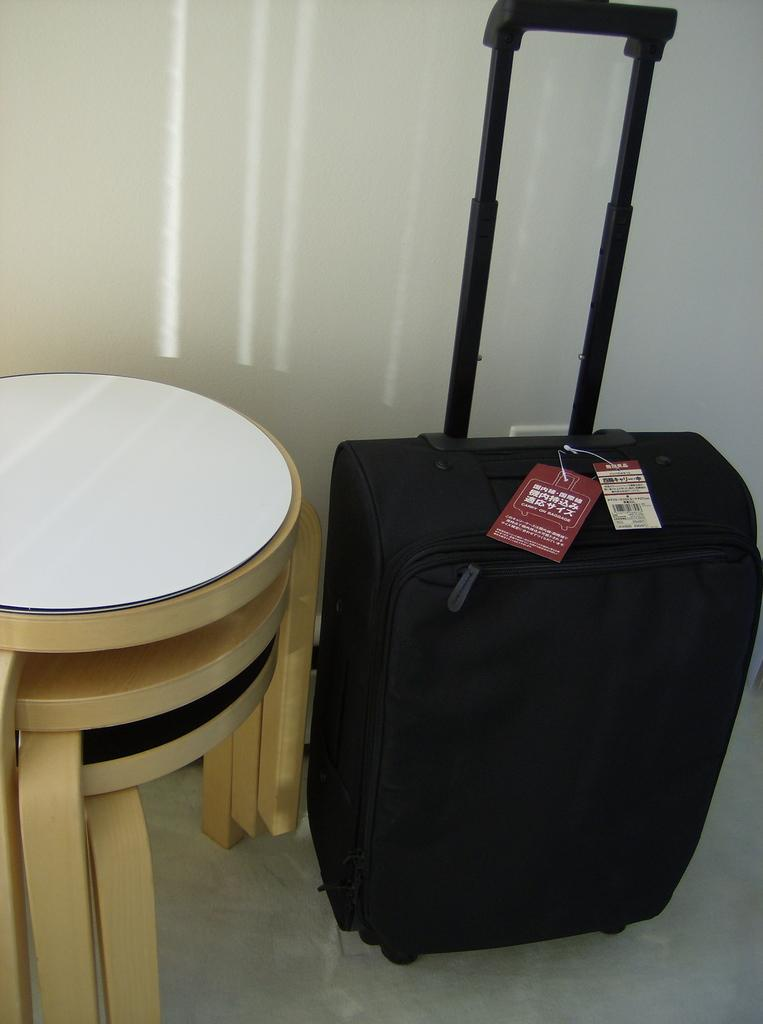What color is the suitcase in the image? The suitcase in the image is black. Are there any markings or labels on the suitcase? Yes, there are labels on top of the suitcase. What type of furniture is located beside the suitcase? There is a brown color stool beside the suitcase. How many horses are present in the image? There are no horses present in the image. What type of representative can be seen in the image? There is no representative present in the image. 